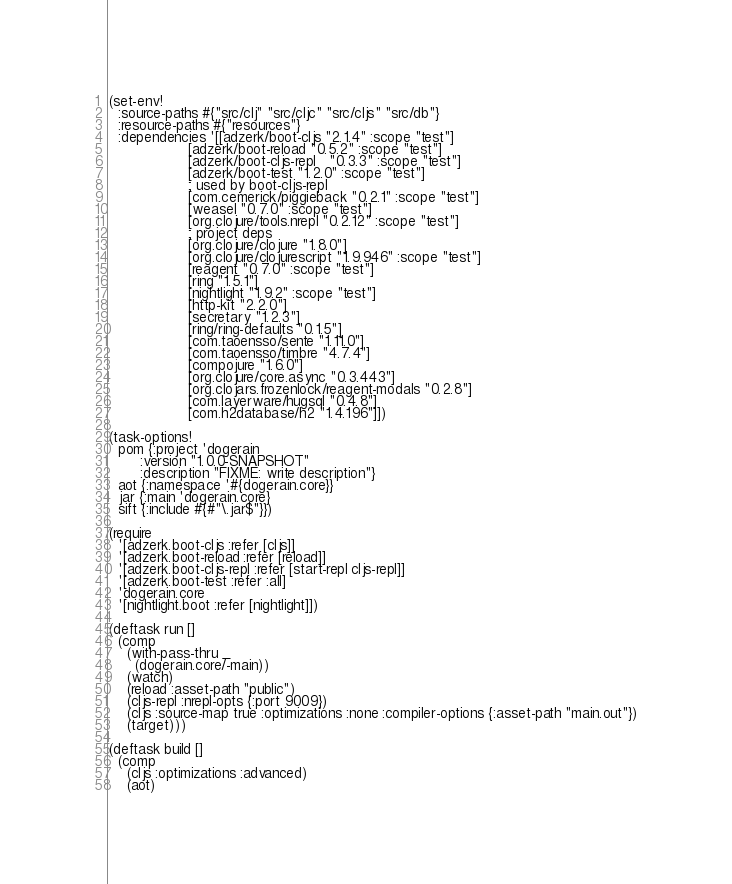<code> <loc_0><loc_0><loc_500><loc_500><_Clojure_>(set-env!
  :source-paths #{"src/clj" "src/cljc" "src/cljs" "src/db"}
  :resource-paths #{"resources"}
  :dependencies '[[adzerk/boot-cljs "2.1.4" :scope "test"]
                  [adzerk/boot-reload "0.5.2" :scope "test"]
                  [adzerk/boot-cljs-repl   "0.3.3" :scope "test"]
                  [adzerk/boot-test "1.2.0" :scope "test"]
                  ; used by boot-cljs-repl
                  [com.cemerick/piggieback "0.2.1" :scope "test"]
                  [weasel "0.7.0" :scope "test"]
                  [org.clojure/tools.nrepl "0.2.12" :scope "test"]
                  ; project deps
                  [org.clojure/clojure "1.8.0"]
                  [org.clojure/clojurescript "1.9.946" :scope "test"]
                  [reagent "0.7.0" :scope "test"]
                  [ring "1.5.1"]
                  [nightlight "1.9.2" :scope "test"]
                  [http-kit "2.2.0"]
                  [secretary "1.2.3"]
                  [ring/ring-defaults "0.1.5"]
                  [com.taoensso/sente "1.11.0"]
                  [com.taoensso/timbre "4.7.4"]
                  [compojure "1.6.0"]
                  [org.clojure/core.async "0.3.443"]
                  [org.clojars.frozenlock/reagent-modals "0.2.8"]
                  [com.layerware/hugsql "0.4.8"]
                  [com.h2database/h2 "1.4.196"]])

(task-options!
  pom {:project 'dogerain
       :version "1.0.0-SNAPSHOT"
       :description "FIXME: write description"}
  aot {:namespace '#{dogerain.core}}
  jar {:main 'dogerain.core}
  sift {:include #{#"\.jar$"}})

(require
  '[adzerk.boot-cljs :refer [cljs]]
  '[adzerk.boot-reload :refer [reload]]
  '[adzerk.boot-cljs-repl :refer [start-repl cljs-repl]]
  '[adzerk.boot-test :refer :all]
  'dogerain.core
  '[nightlight.boot :refer [nightlight]])

(deftask run []
  (comp
    (with-pass-thru _
      (dogerain.core/-main))
    (watch)
    (reload :asset-path "public")
    (cljs-repl :nrepl-opts {:port 9009})
    (cljs :source-map true :optimizations :none :compiler-options {:asset-path "main.out"})
    (target)))

(deftask build []
  (comp
    (cljs :optimizations :advanced)
    (aot)</code> 